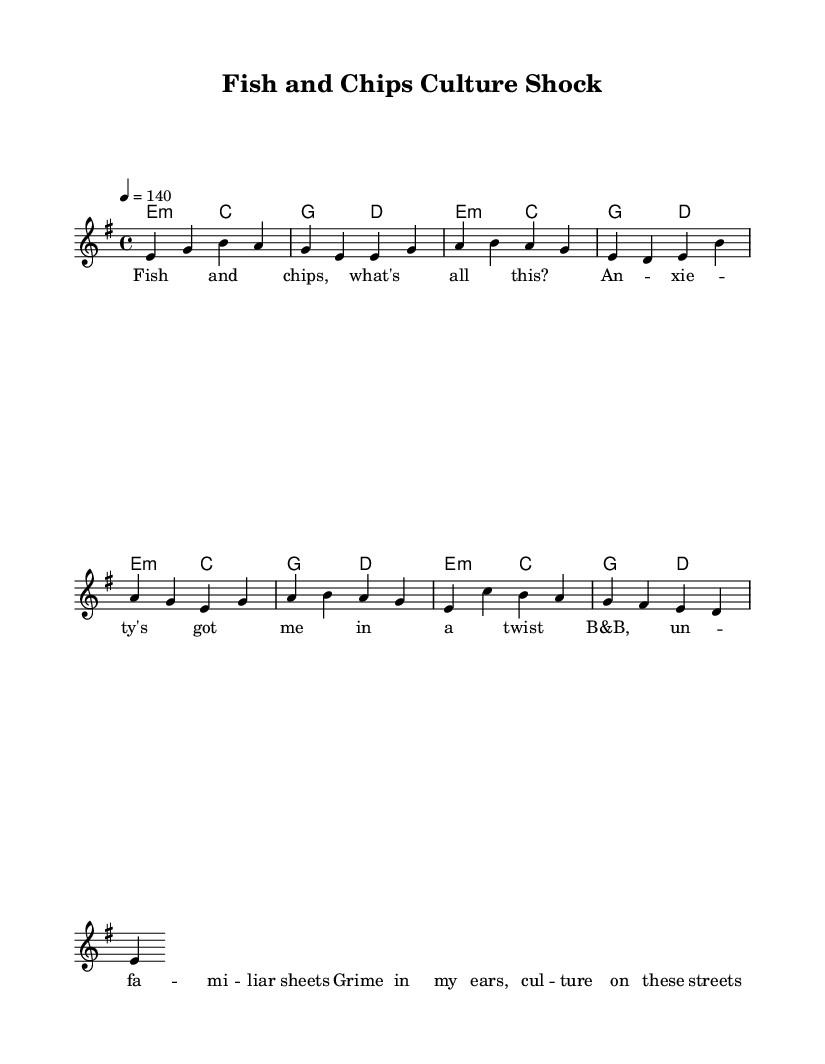What is the key signature of this music? The key signature is indicated by the initial information in the score. In this sheet, a minor key is used, specifically e minor, which has one sharp (F#).
Answer: e minor What is the time signature of this music? The time signature is displayed at the beginning of the music score. It states 4/4, which indicates that there are four beats in each measure and a quarter note gets one beat.
Answer: 4/4 What is the tempo marking of this music? The tempo is noted with "4 = 140," indicating that the quarter note is played at a speed of 140 beats per minute.
Answer: 140 How many measures are in the verse section? Counting the bars in the verse section, we can see that it contains four measures in total.
Answer: 4 What type of musical phrase is used in the lyrics section of the sheet music? The lyrics section contains a poetic format typical in hip hop music, focusing on personal experience and cultural identity. This can be seen in the rhyming scheme and expression of emotions.
Answer: Poetic Which musical elements highlight the cultural identity theme in this piece? The use of specific terms like "fish and chips" and "grime" in the lyrics showcases elements of British culture, while the hip hop style reflects a fusion of musical genres addressing identity and experience.
Answer: Fish and chips, grime What type of harmony is used throughout the score? The harmony is built on minor chords, which is typical for creating a darker, more profound emotional quality in hip hop music. We can see the repeated use of e minor and c major chords in the harmonic structure.
Answer: Minor chords 